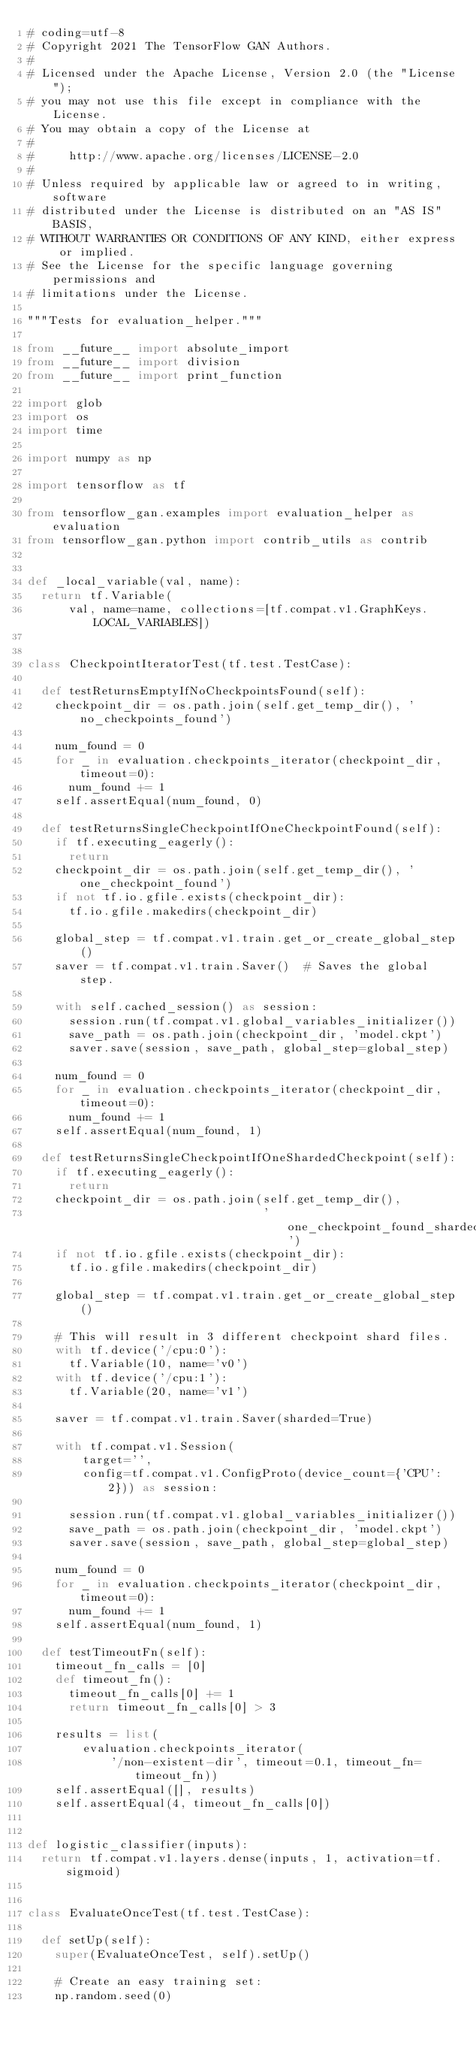<code> <loc_0><loc_0><loc_500><loc_500><_Python_># coding=utf-8
# Copyright 2021 The TensorFlow GAN Authors.
#
# Licensed under the Apache License, Version 2.0 (the "License");
# you may not use this file except in compliance with the License.
# You may obtain a copy of the License at
#
#     http://www.apache.org/licenses/LICENSE-2.0
#
# Unless required by applicable law or agreed to in writing, software
# distributed under the License is distributed on an "AS IS" BASIS,
# WITHOUT WARRANTIES OR CONDITIONS OF ANY KIND, either express or implied.
# See the License for the specific language governing permissions and
# limitations under the License.

"""Tests for evaluation_helper."""

from __future__ import absolute_import
from __future__ import division
from __future__ import print_function

import glob
import os
import time

import numpy as np

import tensorflow as tf

from tensorflow_gan.examples import evaluation_helper as evaluation
from tensorflow_gan.python import contrib_utils as contrib


def _local_variable(val, name):
  return tf.Variable(
      val, name=name, collections=[tf.compat.v1.GraphKeys.LOCAL_VARIABLES])


class CheckpointIteratorTest(tf.test.TestCase):

  def testReturnsEmptyIfNoCheckpointsFound(self):
    checkpoint_dir = os.path.join(self.get_temp_dir(), 'no_checkpoints_found')

    num_found = 0
    for _ in evaluation.checkpoints_iterator(checkpoint_dir, timeout=0):
      num_found += 1
    self.assertEqual(num_found, 0)

  def testReturnsSingleCheckpointIfOneCheckpointFound(self):
    if tf.executing_eagerly():
      return
    checkpoint_dir = os.path.join(self.get_temp_dir(), 'one_checkpoint_found')
    if not tf.io.gfile.exists(checkpoint_dir):
      tf.io.gfile.makedirs(checkpoint_dir)

    global_step = tf.compat.v1.train.get_or_create_global_step()
    saver = tf.compat.v1.train.Saver()  # Saves the global step.

    with self.cached_session() as session:
      session.run(tf.compat.v1.global_variables_initializer())
      save_path = os.path.join(checkpoint_dir, 'model.ckpt')
      saver.save(session, save_path, global_step=global_step)

    num_found = 0
    for _ in evaluation.checkpoints_iterator(checkpoint_dir, timeout=0):
      num_found += 1
    self.assertEqual(num_found, 1)

  def testReturnsSingleCheckpointIfOneShardedCheckpoint(self):
    if tf.executing_eagerly():
      return
    checkpoint_dir = os.path.join(self.get_temp_dir(),
                                  'one_checkpoint_found_sharded')
    if not tf.io.gfile.exists(checkpoint_dir):
      tf.io.gfile.makedirs(checkpoint_dir)

    global_step = tf.compat.v1.train.get_or_create_global_step()

    # This will result in 3 different checkpoint shard files.
    with tf.device('/cpu:0'):
      tf.Variable(10, name='v0')
    with tf.device('/cpu:1'):
      tf.Variable(20, name='v1')

    saver = tf.compat.v1.train.Saver(sharded=True)

    with tf.compat.v1.Session(
        target='',
        config=tf.compat.v1.ConfigProto(device_count={'CPU': 2})) as session:

      session.run(tf.compat.v1.global_variables_initializer())
      save_path = os.path.join(checkpoint_dir, 'model.ckpt')
      saver.save(session, save_path, global_step=global_step)

    num_found = 0
    for _ in evaluation.checkpoints_iterator(checkpoint_dir, timeout=0):
      num_found += 1
    self.assertEqual(num_found, 1)

  def testTimeoutFn(self):
    timeout_fn_calls = [0]
    def timeout_fn():
      timeout_fn_calls[0] += 1
      return timeout_fn_calls[0] > 3

    results = list(
        evaluation.checkpoints_iterator(
            '/non-existent-dir', timeout=0.1, timeout_fn=timeout_fn))
    self.assertEqual([], results)
    self.assertEqual(4, timeout_fn_calls[0])


def logistic_classifier(inputs):
  return tf.compat.v1.layers.dense(inputs, 1, activation=tf.sigmoid)


class EvaluateOnceTest(tf.test.TestCase):

  def setUp(self):
    super(EvaluateOnceTest, self).setUp()

    # Create an easy training set:
    np.random.seed(0)
</code> 